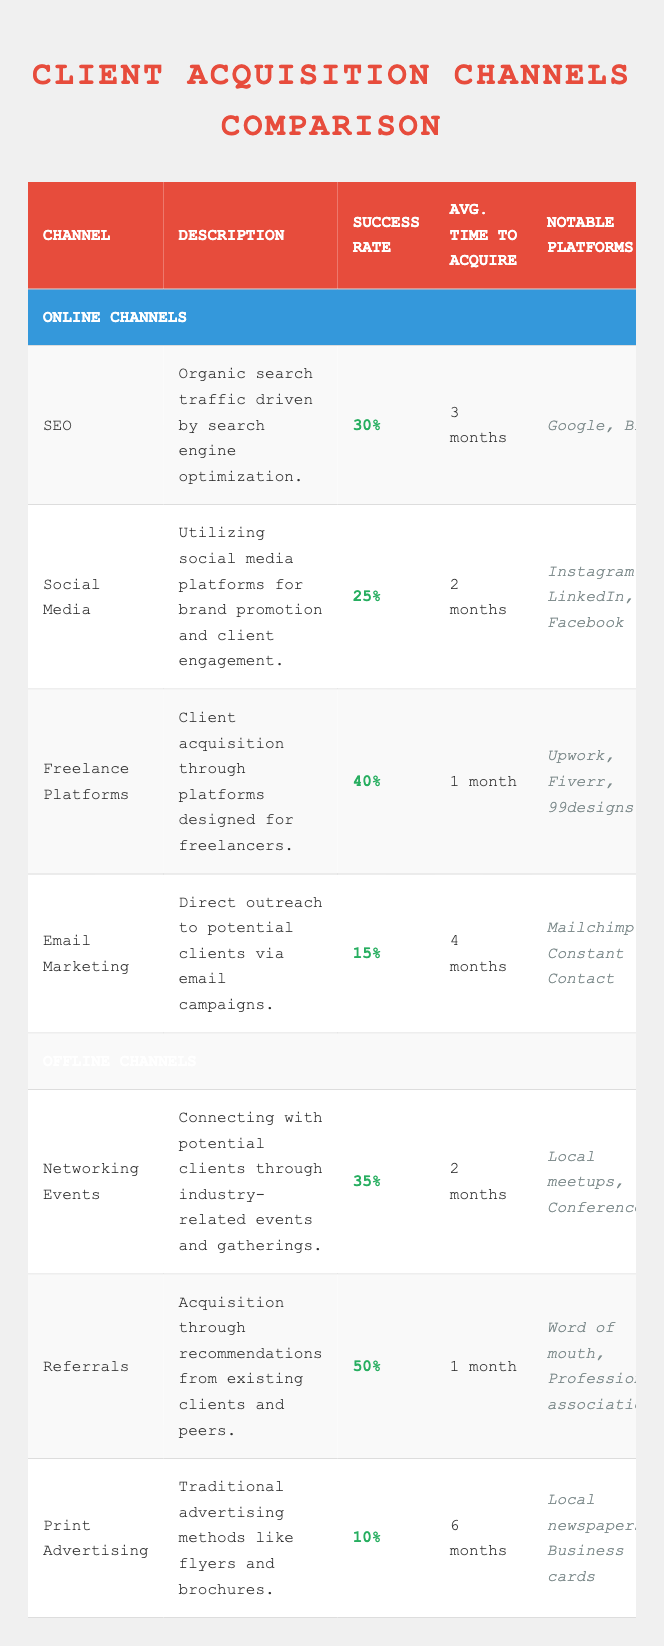What is the success rate of Referrals? The success rate of Referrals is listed directly in the table under the "Success Rate" column. When looking at the row for Referrals, it shows a success rate of 50%.
Answer: 50% Which online client acquisition channel has the highest success rate? By reviewing the online channels listed, we find that Freelance Platforms has the highest success rate at 40% compared to SEO (30%), Social Media (25%), and Email Marketing (15%).
Answer: Freelance Platforms What is the average time to acquire a client through Networking Events and Social Media? To find the average time, we take the time from Networking Events (2 months) and Social Media (2 months). Adding these gives us 2 + 2 = 4 months. Since we have 2 data points, we divide by 2: 4 months / 2 = 2 months.
Answer: 2 months Is the success rate of Email Marketing greater than the success rate of Print Advertising? The success rate of Email Marketing is 15% and that of Print Advertising is 10%. Since 15% is greater than 10%, we can conclude that the statement is true.
Answer: Yes What is the total success rate of all online channels combined, assuming they are equally weighted? The success rates of the online channels are: SEO (30%), Social Media (25%), Freelance Platforms (40%), and Email Marketing (15%). The total sum is 30 + 25 + 40 + 15 = 110%. To find the average success rate, we divide the total by the number of channels: 110% / 4 = 27.5%.
Answer: 27.5% Which offline channel takes the longest average time to acquire a client? By examining the average times listed for each offline channel, we see that Print Advertising takes the longest time at 6 months. Networking Events and Referrals both take 2 months, while Print Advertising is significantly higher.
Answer: Print Advertising Can you identify an online acquisition channel that has a success rate below 20%? We look through the success rates of all online channels, finding that the lowest is Email Marketing with a success rate of only 15%. Therefore, it meets the criterion of being below 20%.
Answer: Yes How do the success rates of Offline channels compare with Online channels? The success rates of the offline channels are: Networking Events (35%), Referrals (50%), Print Advertising (10%). The highest offline success rate (50%) exceeds the highest online (40% from Freelance Platforms), while the lowest offline (10%) is lower than the lowest online (15% from Email Marketing). This shows a mix of performance between the categories.
Answer: Mixed performance What is the most significant difference in success rate between the best online and the best offline channel? The best online channel is Freelance Platforms with a success rate of 40%, while the best offline channel is Referrals with 50%. The difference is calculated as 50% - 40% = 10%.
Answer: 10% 